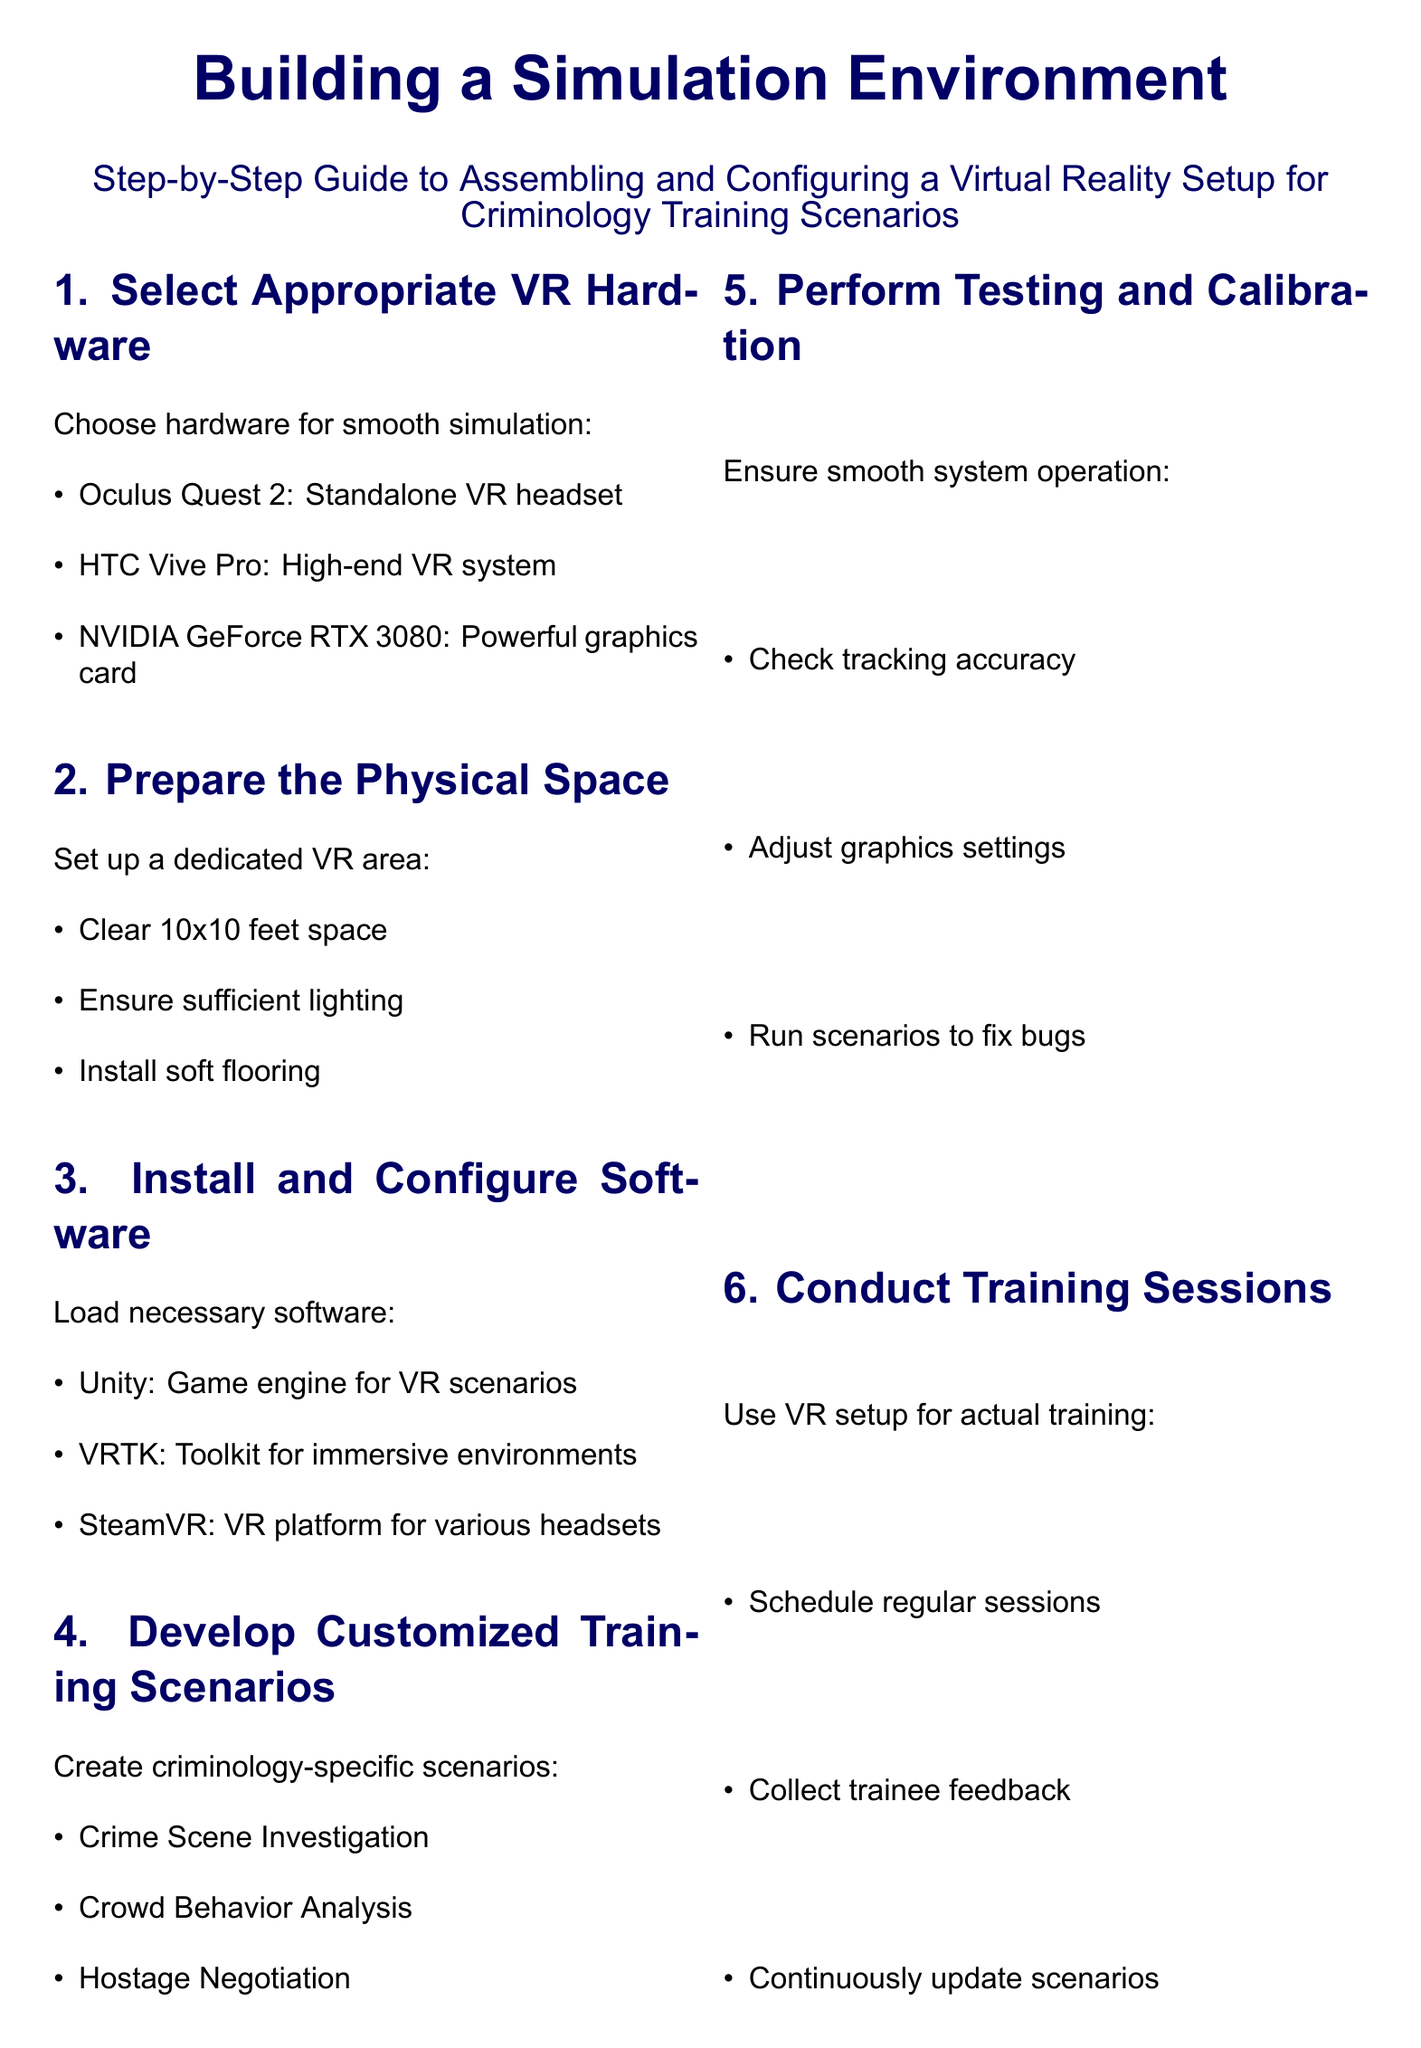What is the first step in building a simulation environment? The first step is to select appropriate VR hardware.
Answer: Select Appropriate VR Hardware Which VR headset is mentioned as a standalone option? The chosen standalone VR headset mentioned in the document is the Oculus Quest 2.
Answer: Oculus Quest 2 What is the recommended software for VR scenarios? The software that is specifically recommended for VR scenarios in the document is Unity.
Answer: Unity How big should the dedicated VR area be? The document specifies that the dedicated VR area should be a clear 10x10 feet space.
Answer: 10x10 feet What type of scenarios should be developed for training? The document mentions that criminology-specific scenarios should be created, such as crime scene investigation.
Answer: Crime Scene Investigation What hardware is suggested for high-end VR systems? The suggested high-end VR system mentioned in the document is the HTC Vive Pro.
Answer: HTC Vive Pro What is one of the expert tips provided? One of the expert tips provided in the document is to regularly update VR hardware and software.
Answer: Regularly update VR hardware and software What should be done before beginning VR sessions? The document recommends briefing users on potential motion sickness before beginning VR sessions.
Answer: Brief users on potential motion sickness How should feedback be used during training sessions? The document suggests collecting trainee feedback to continuously update scenarios during training sessions.
Answer: Collect trainee feedback 